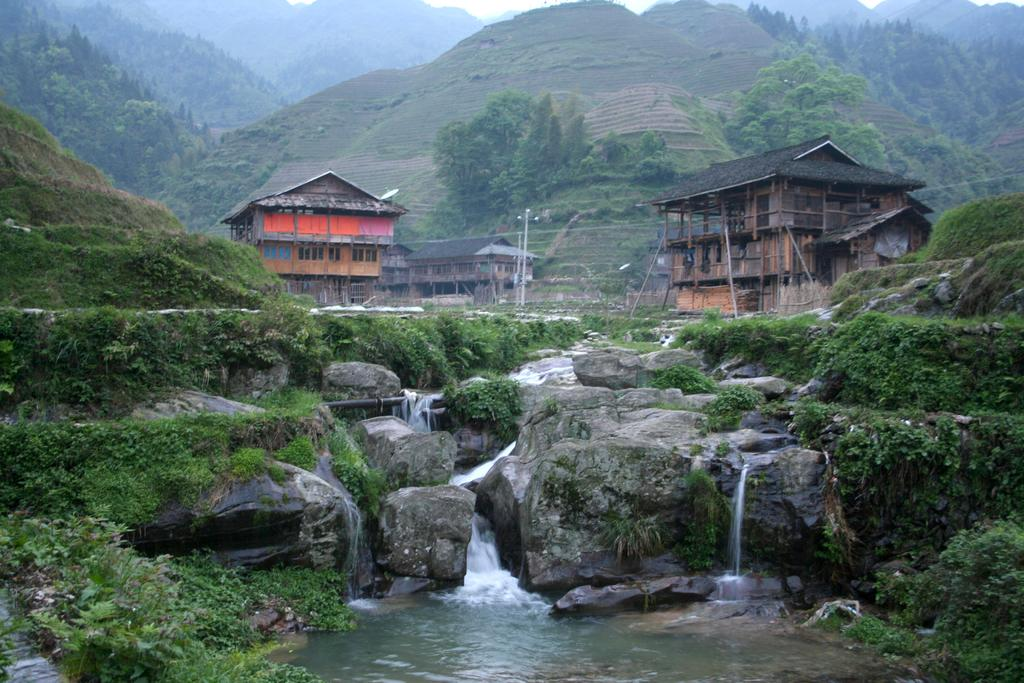What type of terrain is visible in the image? There are many hills in the image, along with grassy land. What type of vegetation can be seen in the image? There are trees and plants in the image. Are there any structures visible in the image? Yes, there are houses in the image. What natural feature is present in the image? There is a water flow in the image. Can you hear the ocean in the image? There is no ocean present in the image, so it is not possible to hear it. 